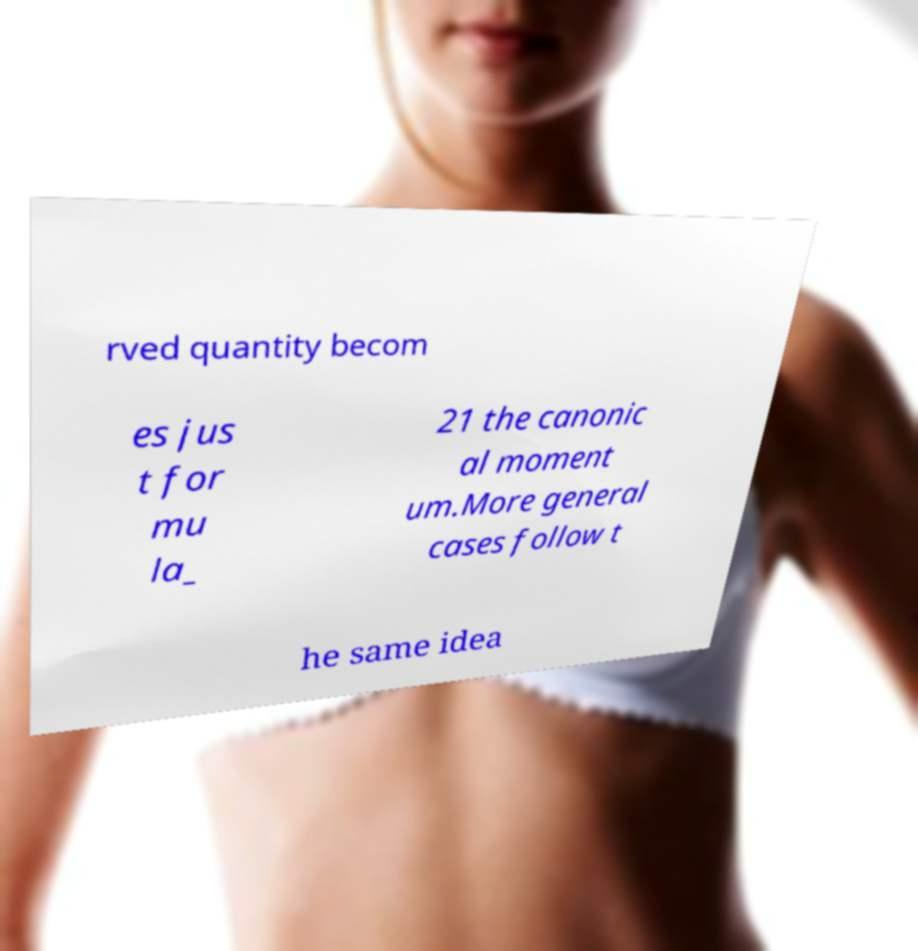I need the written content from this picture converted into text. Can you do that? rved quantity becom es jus t for mu la_ 21 the canonic al moment um.More general cases follow t he same idea 